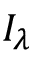Convert formula to latex. <formula><loc_0><loc_0><loc_500><loc_500>I _ { \lambda }</formula> 